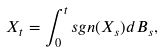Convert formula to latex. <formula><loc_0><loc_0><loc_500><loc_500>X _ { t } = \int _ { 0 } ^ { t } s g n ( X _ { s } ) d B _ { s } ,</formula> 